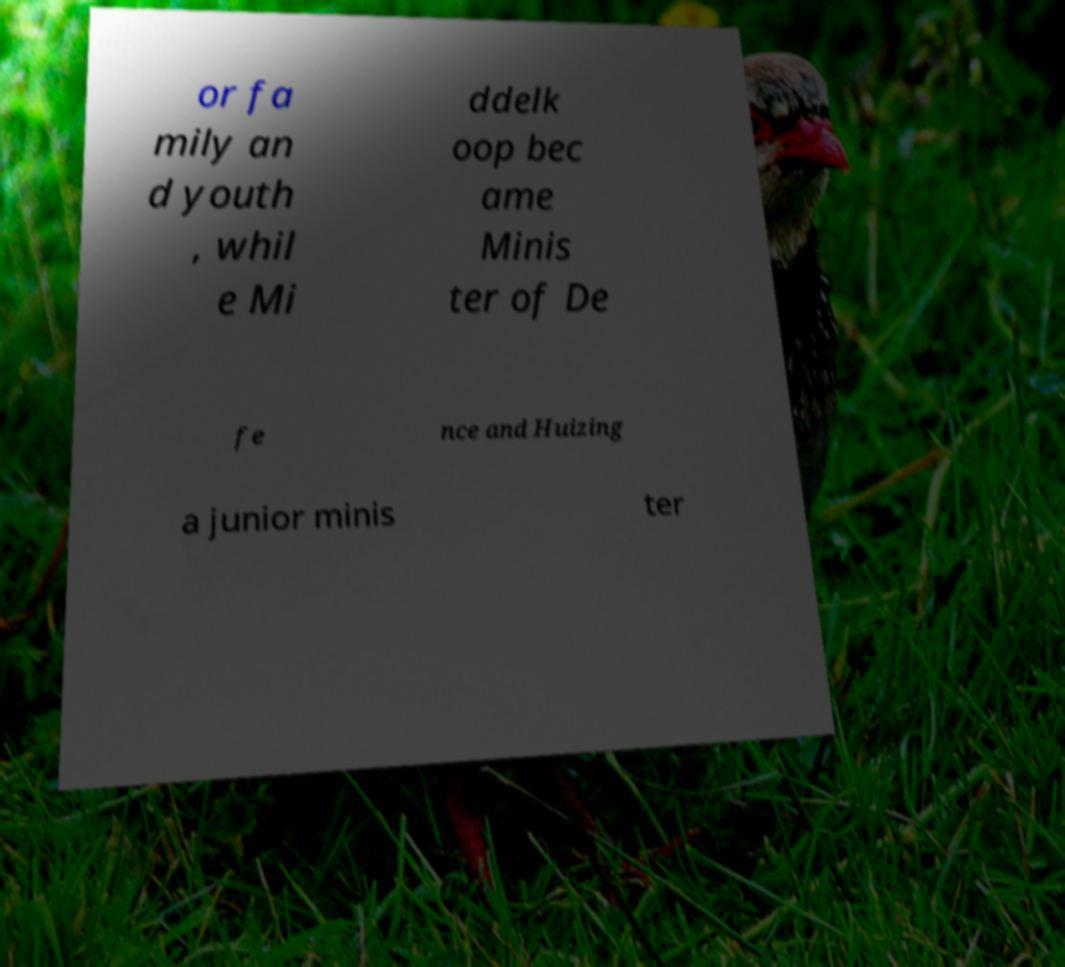For documentation purposes, I need the text within this image transcribed. Could you provide that? or fa mily an d youth , whil e Mi ddelk oop bec ame Minis ter of De fe nce and Huizing a junior minis ter 